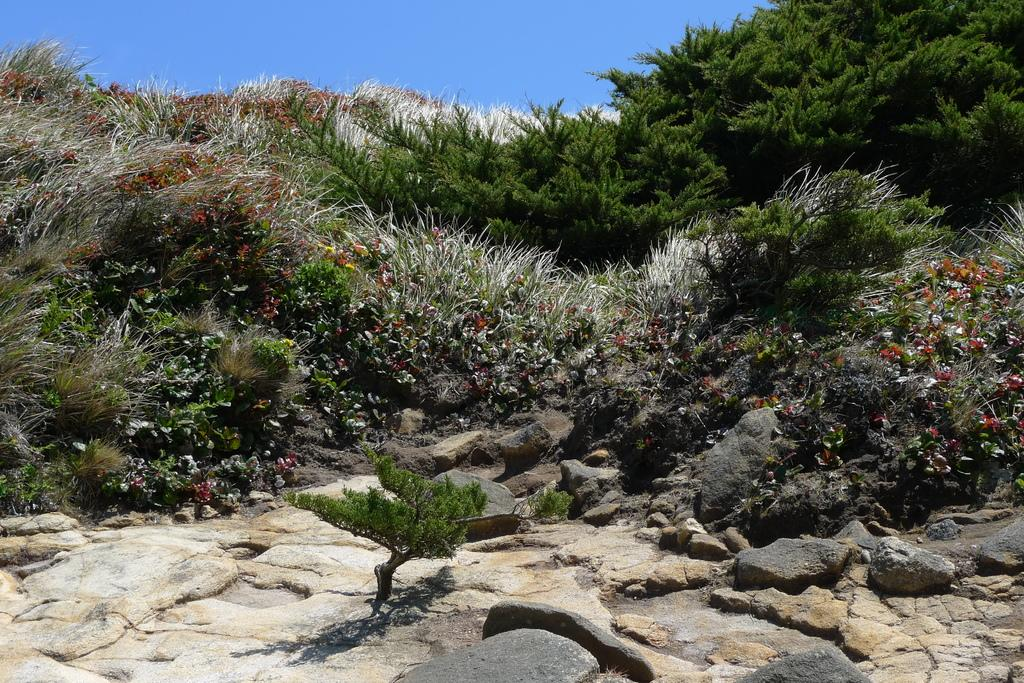What type of vegetation can be seen in the image? There are many plants in the image. Are there any specific features of the plants? Yes, there are flowers in the image. What is located at the bottom of the image? There are rocks at the bottom of the image. What is visible at the top of the image? The sky is visible at the top of the image. What day of the week is depicted in the image? The image does not depict a specific day of the week; it shows plants, flowers, rocks, and the sky. 